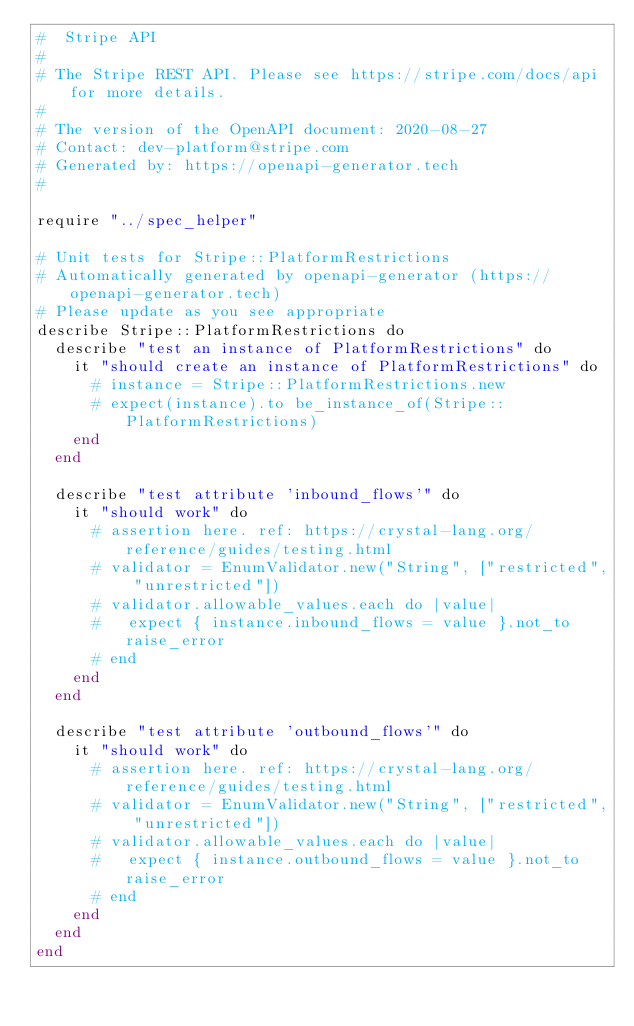Convert code to text. <code><loc_0><loc_0><loc_500><loc_500><_Crystal_>#  Stripe API
#
# The Stripe REST API. Please see https://stripe.com/docs/api for more details.
#
# The version of the OpenAPI document: 2020-08-27
# Contact: dev-platform@stripe.com
# Generated by: https://openapi-generator.tech
#

require "../spec_helper"

# Unit tests for Stripe::PlatformRestrictions
# Automatically generated by openapi-generator (https://openapi-generator.tech)
# Please update as you see appropriate
describe Stripe::PlatformRestrictions do
  describe "test an instance of PlatformRestrictions" do
    it "should create an instance of PlatformRestrictions" do
      # instance = Stripe::PlatformRestrictions.new
      # expect(instance).to be_instance_of(Stripe::PlatformRestrictions)
    end
  end

  describe "test attribute 'inbound_flows'" do
    it "should work" do
      # assertion here. ref: https://crystal-lang.org/reference/guides/testing.html
      # validator = EnumValidator.new("String", ["restricted", "unrestricted"])
      # validator.allowable_values.each do |value|
      #   expect { instance.inbound_flows = value }.not_to raise_error
      # end
    end
  end

  describe "test attribute 'outbound_flows'" do
    it "should work" do
      # assertion here. ref: https://crystal-lang.org/reference/guides/testing.html
      # validator = EnumValidator.new("String", ["restricted", "unrestricted"])
      # validator.allowable_values.each do |value|
      #   expect { instance.outbound_flows = value }.not_to raise_error
      # end
    end
  end
end
</code> 